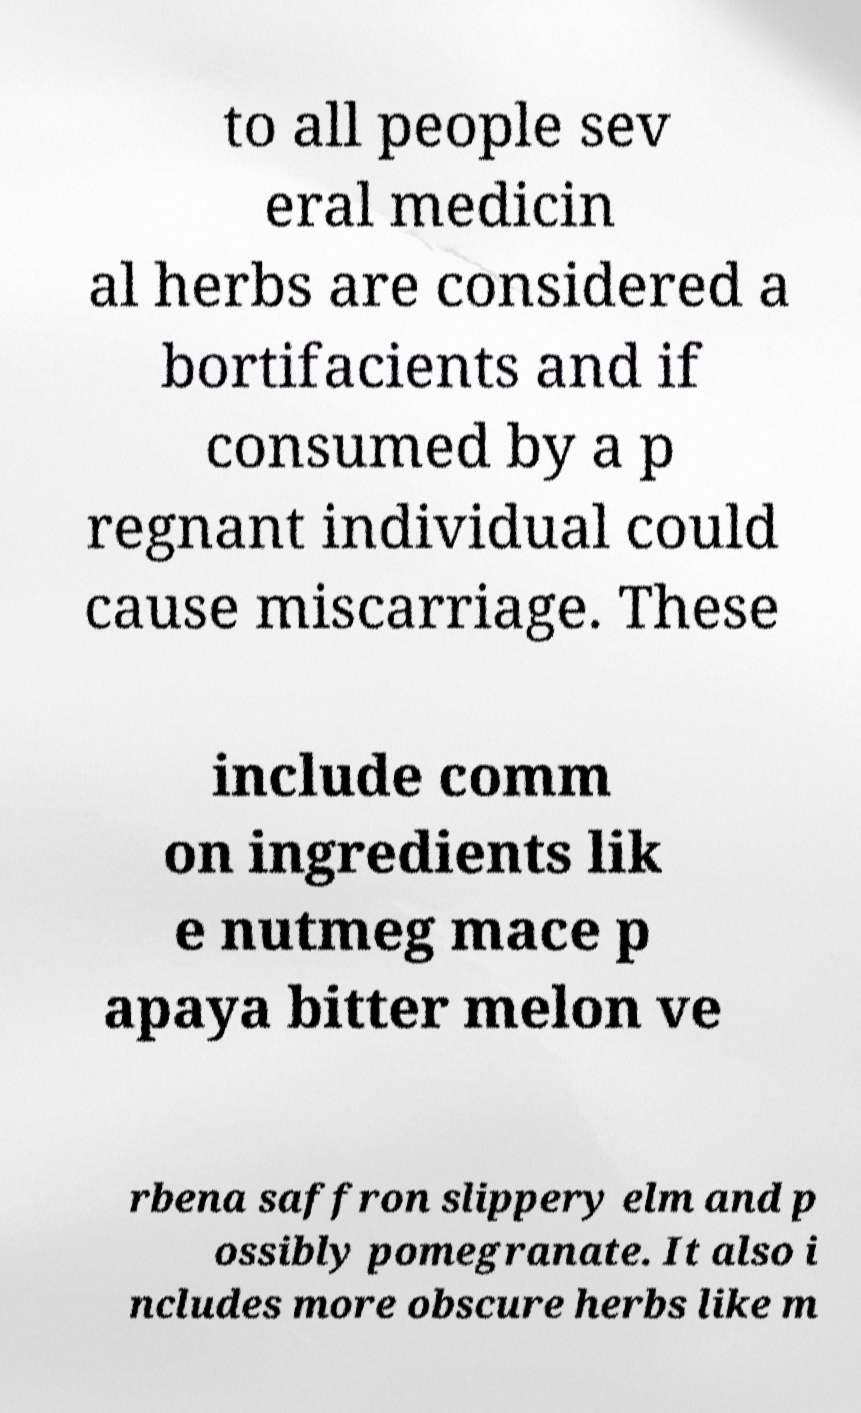Could you assist in decoding the text presented in this image and type it out clearly? to all people sev eral medicin al herbs are considered a bortifacients and if consumed by a p regnant individual could cause miscarriage. These include comm on ingredients lik e nutmeg mace p apaya bitter melon ve rbena saffron slippery elm and p ossibly pomegranate. It also i ncludes more obscure herbs like m 